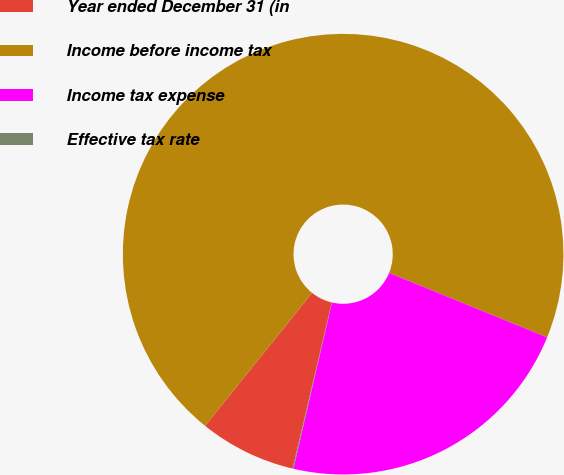<chart> <loc_0><loc_0><loc_500><loc_500><pie_chart><fcel>Year ended December 31 (in<fcel>Income before income tax<fcel>Income tax expense<fcel>Effective tax rate<nl><fcel>7.09%<fcel>70.38%<fcel>22.46%<fcel>0.06%<nl></chart> 